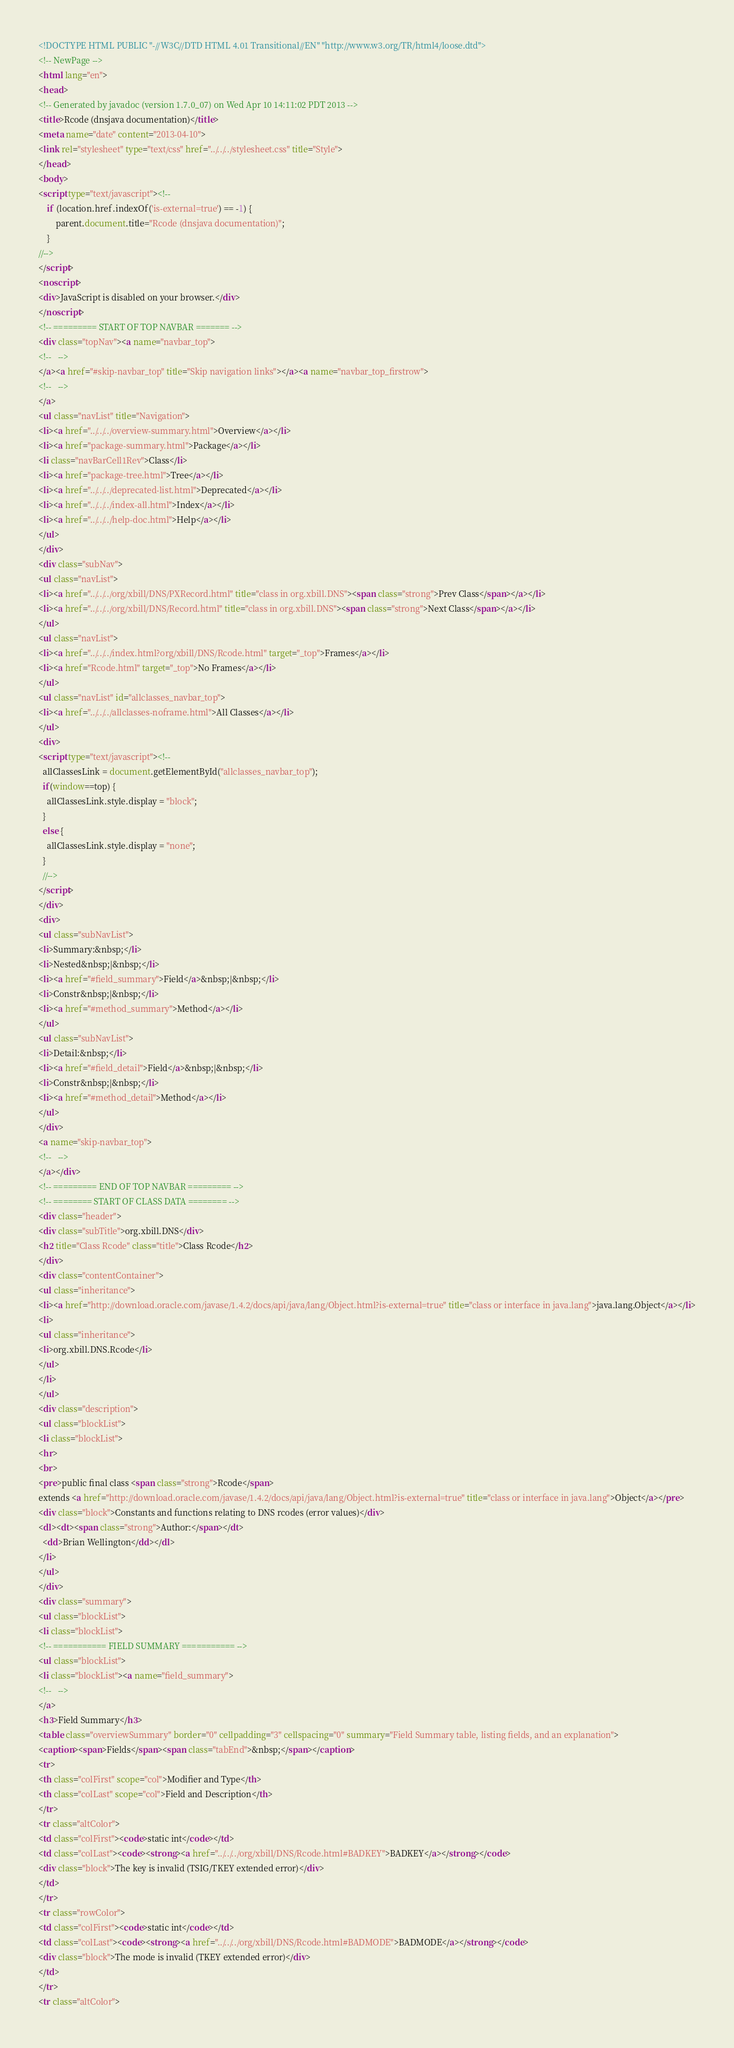Convert code to text. <code><loc_0><loc_0><loc_500><loc_500><_HTML_><!DOCTYPE HTML PUBLIC "-//W3C//DTD HTML 4.01 Transitional//EN" "http://www.w3.org/TR/html4/loose.dtd">
<!-- NewPage -->
<html lang="en">
<head>
<!-- Generated by javadoc (version 1.7.0_07) on Wed Apr 10 14:11:02 PDT 2013 -->
<title>Rcode (dnsjava documentation)</title>
<meta name="date" content="2013-04-10">
<link rel="stylesheet" type="text/css" href="../../../stylesheet.css" title="Style">
</head>
<body>
<script type="text/javascript"><!--
    if (location.href.indexOf('is-external=true') == -1) {
        parent.document.title="Rcode (dnsjava documentation)";
    }
//-->
</script>
<noscript>
<div>JavaScript is disabled on your browser.</div>
</noscript>
<!-- ========= START OF TOP NAVBAR ======= -->
<div class="topNav"><a name="navbar_top">
<!--   -->
</a><a href="#skip-navbar_top" title="Skip navigation links"></a><a name="navbar_top_firstrow">
<!--   -->
</a>
<ul class="navList" title="Navigation">
<li><a href="../../../overview-summary.html">Overview</a></li>
<li><a href="package-summary.html">Package</a></li>
<li class="navBarCell1Rev">Class</li>
<li><a href="package-tree.html">Tree</a></li>
<li><a href="../../../deprecated-list.html">Deprecated</a></li>
<li><a href="../../../index-all.html">Index</a></li>
<li><a href="../../../help-doc.html">Help</a></li>
</ul>
</div>
<div class="subNav">
<ul class="navList">
<li><a href="../../../org/xbill/DNS/PXRecord.html" title="class in org.xbill.DNS"><span class="strong">Prev Class</span></a></li>
<li><a href="../../../org/xbill/DNS/Record.html" title="class in org.xbill.DNS"><span class="strong">Next Class</span></a></li>
</ul>
<ul class="navList">
<li><a href="../../../index.html?org/xbill/DNS/Rcode.html" target="_top">Frames</a></li>
<li><a href="Rcode.html" target="_top">No Frames</a></li>
</ul>
<ul class="navList" id="allclasses_navbar_top">
<li><a href="../../../allclasses-noframe.html">All Classes</a></li>
</ul>
<div>
<script type="text/javascript"><!--
  allClassesLink = document.getElementById("allclasses_navbar_top");
  if(window==top) {
    allClassesLink.style.display = "block";
  }
  else {
    allClassesLink.style.display = "none";
  }
  //-->
</script>
</div>
<div>
<ul class="subNavList">
<li>Summary:&nbsp;</li>
<li>Nested&nbsp;|&nbsp;</li>
<li><a href="#field_summary">Field</a>&nbsp;|&nbsp;</li>
<li>Constr&nbsp;|&nbsp;</li>
<li><a href="#method_summary">Method</a></li>
</ul>
<ul class="subNavList">
<li>Detail:&nbsp;</li>
<li><a href="#field_detail">Field</a>&nbsp;|&nbsp;</li>
<li>Constr&nbsp;|&nbsp;</li>
<li><a href="#method_detail">Method</a></li>
</ul>
</div>
<a name="skip-navbar_top">
<!--   -->
</a></div>
<!-- ========= END OF TOP NAVBAR ========= -->
<!-- ======== START OF CLASS DATA ======== -->
<div class="header">
<div class="subTitle">org.xbill.DNS</div>
<h2 title="Class Rcode" class="title">Class Rcode</h2>
</div>
<div class="contentContainer">
<ul class="inheritance">
<li><a href="http://download.oracle.com/javase/1.4.2/docs/api/java/lang/Object.html?is-external=true" title="class or interface in java.lang">java.lang.Object</a></li>
<li>
<ul class="inheritance">
<li>org.xbill.DNS.Rcode</li>
</ul>
</li>
</ul>
<div class="description">
<ul class="blockList">
<li class="blockList">
<hr>
<br>
<pre>public final class <span class="strong">Rcode</span>
extends <a href="http://download.oracle.com/javase/1.4.2/docs/api/java/lang/Object.html?is-external=true" title="class or interface in java.lang">Object</a></pre>
<div class="block">Constants and functions relating to DNS rcodes (error values)</div>
<dl><dt><span class="strong">Author:</span></dt>
  <dd>Brian Wellington</dd></dl>
</li>
</ul>
</div>
<div class="summary">
<ul class="blockList">
<li class="blockList">
<!-- =========== FIELD SUMMARY =========== -->
<ul class="blockList">
<li class="blockList"><a name="field_summary">
<!--   -->
</a>
<h3>Field Summary</h3>
<table class="overviewSummary" border="0" cellpadding="3" cellspacing="0" summary="Field Summary table, listing fields, and an explanation">
<caption><span>Fields</span><span class="tabEnd">&nbsp;</span></caption>
<tr>
<th class="colFirst" scope="col">Modifier and Type</th>
<th class="colLast" scope="col">Field and Description</th>
</tr>
<tr class="altColor">
<td class="colFirst"><code>static int</code></td>
<td class="colLast"><code><strong><a href="../../../org/xbill/DNS/Rcode.html#BADKEY">BADKEY</a></strong></code>
<div class="block">The key is invalid (TSIG/TKEY extended error)</div>
</td>
</tr>
<tr class="rowColor">
<td class="colFirst"><code>static int</code></td>
<td class="colLast"><code><strong><a href="../../../org/xbill/DNS/Rcode.html#BADMODE">BADMODE</a></strong></code>
<div class="block">The mode is invalid (TKEY extended error)</div>
</td>
</tr>
<tr class="altColor"></code> 